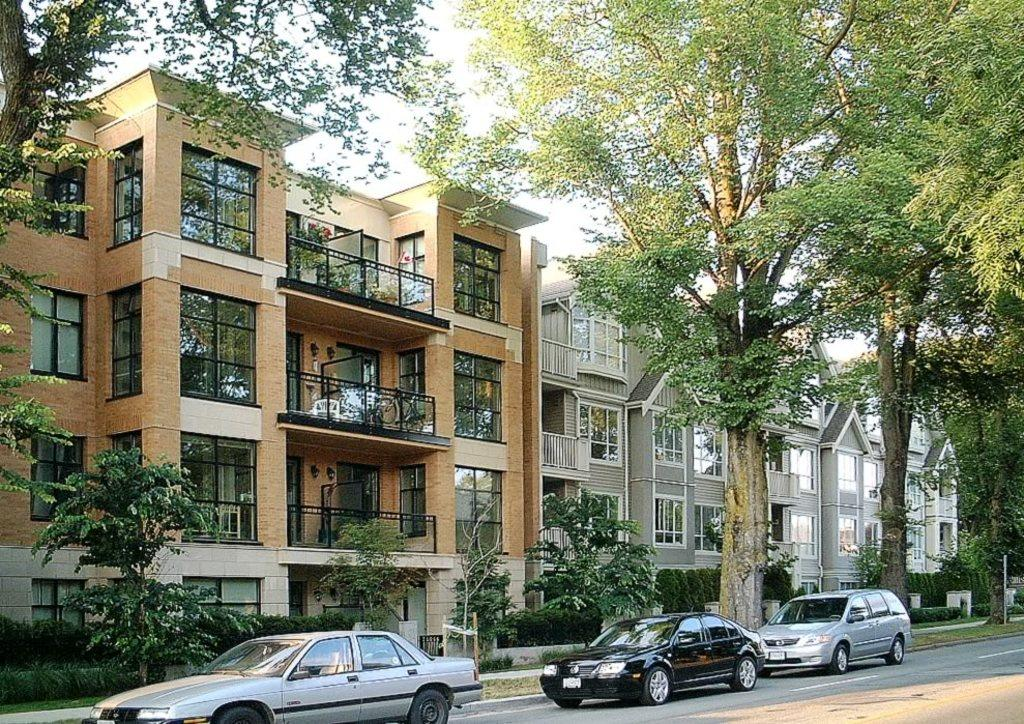How many cars can be seen on the road in the image? There are three cars on the road in the image. What type of natural elements are visible in the image? Trees are visible in the image. What type of structures can be seen in the background of the image? There are buildings in the background of the image. What part of the natural environment is visible in the image? The sky is visible in the image. What type of camp can be seen in the image? There is no camp present in the image. How are the cars sorting themselves in the image? The cars are not sorting themselves in the image; they are simply parked or driving on the road. 